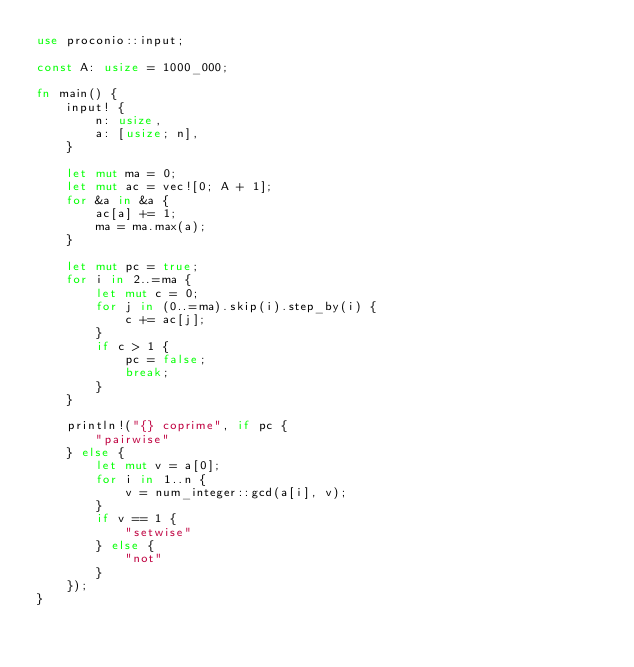Convert code to text. <code><loc_0><loc_0><loc_500><loc_500><_Rust_>use proconio::input;

const A: usize = 1000_000;

fn main() {
    input! {
        n: usize,
        a: [usize; n],
    }

    let mut ma = 0;
    let mut ac = vec![0; A + 1];
    for &a in &a {
        ac[a] += 1;
        ma = ma.max(a);
    }

    let mut pc = true;
    for i in 2..=ma {
        let mut c = 0;
        for j in (0..=ma).skip(i).step_by(i) {
            c += ac[j];
        }
        if c > 1 {
            pc = false;
            break;
        }
    }

    println!("{} coprime", if pc {
        "pairwise"
    } else {
        let mut v = a[0];
        for i in 1..n {
            v = num_integer::gcd(a[i], v);
        }
        if v == 1 {
            "setwise"
        } else {
            "not"
        }
    });
}
</code> 